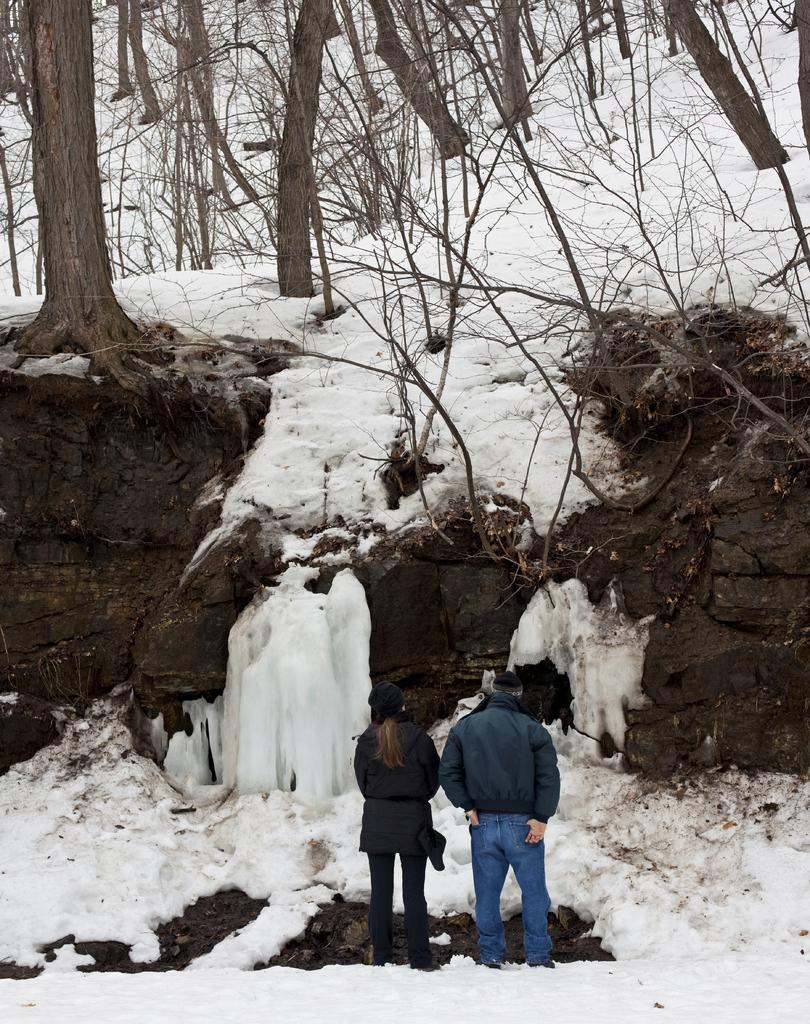How many people are in the image? There are two people in the image. What are the people doing in the image? Both people are standing. What type of clothing are the people wearing in the image? Both people are wearing jackets and caps. What is the weather like in the image? There is snow on the ground, indicating cold weather. What can be seen in the background of the image? There are trees visible in the image. How does the digestion process work for the trees in the image? Trees do not have a digestion process, as they are plants and not living organisms with a digestive system. What is the roll brake system in the image? There is no reference to a roll brake system in the image. 